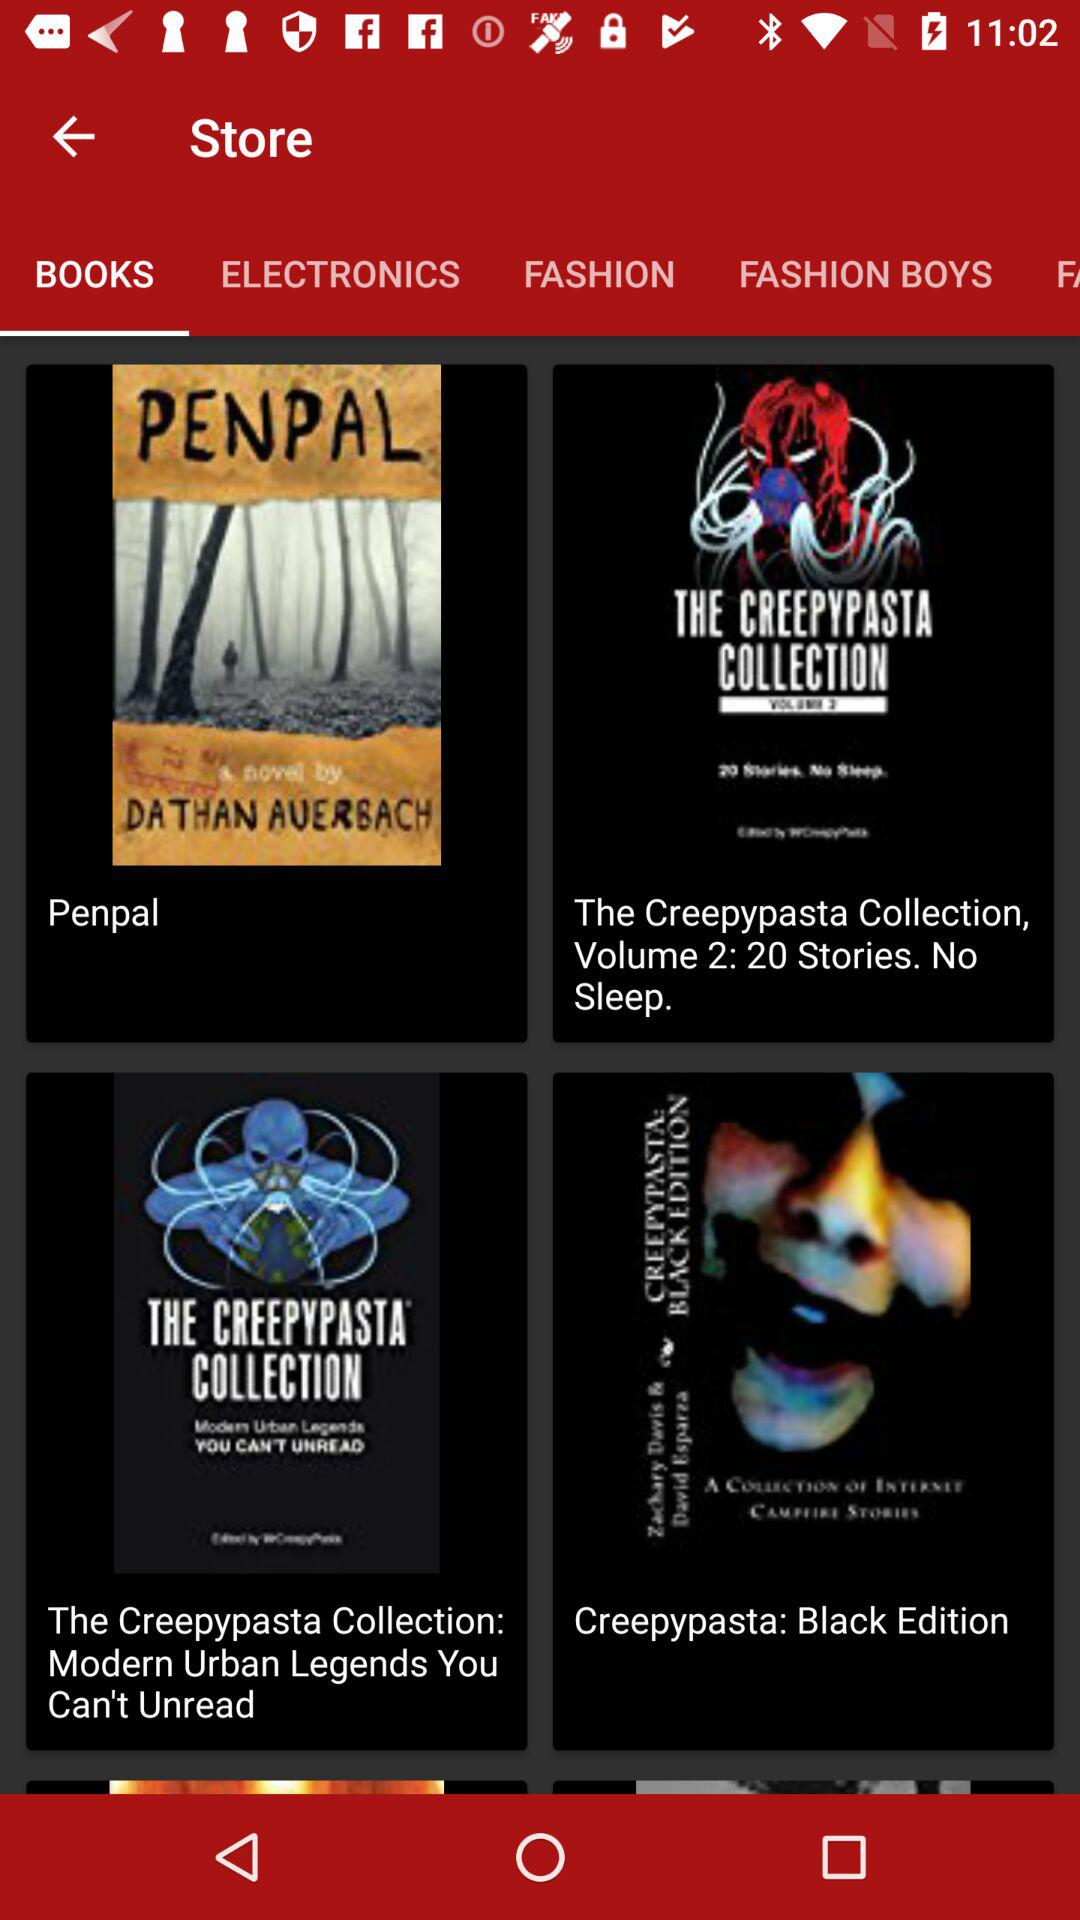What is the selected tab? The selected tab is "BOOK". 